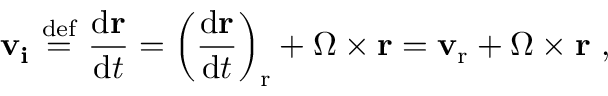<formula> <loc_0><loc_0><loc_500><loc_500>v _ { i } \ { \stackrel { d e f } { = } } \ { \frac { d r } { d t } } = \left ( { \frac { d r } { d t } } \right ) _ { r } + { \Omega } \times r = v _ { r } + { \Omega } \times r \ ,</formula> 